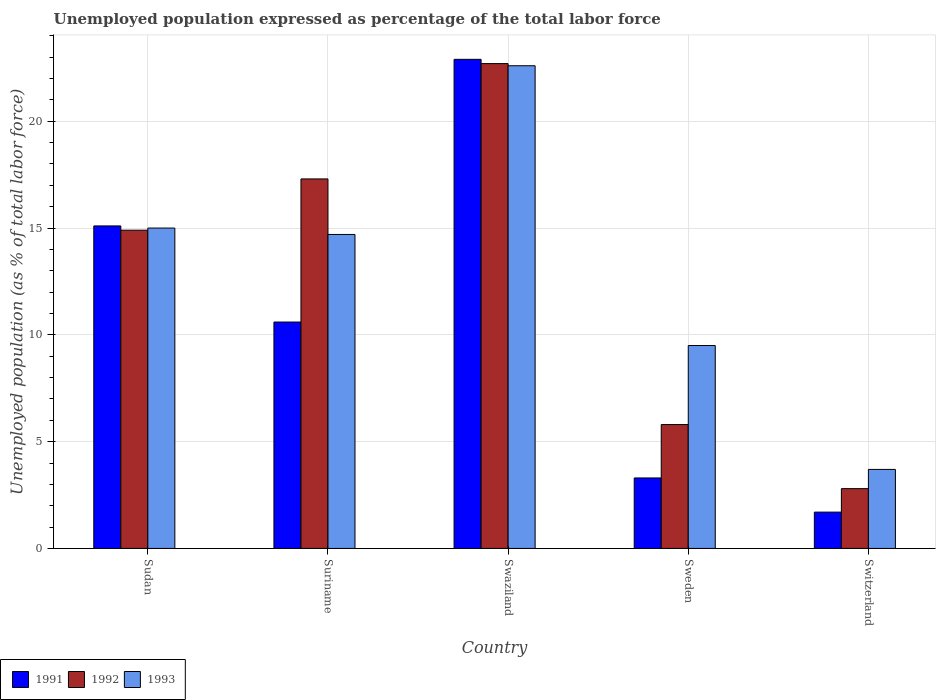Are the number of bars per tick equal to the number of legend labels?
Give a very brief answer. Yes. How many bars are there on the 3rd tick from the left?
Make the answer very short. 3. How many bars are there on the 2nd tick from the right?
Your answer should be compact. 3. What is the label of the 3rd group of bars from the left?
Your response must be concise. Swaziland. In how many cases, is the number of bars for a given country not equal to the number of legend labels?
Offer a terse response. 0. What is the unemployment in in 1992 in Sudan?
Provide a short and direct response. 14.9. Across all countries, what is the maximum unemployment in in 1992?
Offer a very short reply. 22.7. Across all countries, what is the minimum unemployment in in 1991?
Give a very brief answer. 1.7. In which country was the unemployment in in 1993 maximum?
Give a very brief answer. Swaziland. In which country was the unemployment in in 1992 minimum?
Provide a succinct answer. Switzerland. What is the total unemployment in in 1991 in the graph?
Offer a terse response. 53.6. What is the difference between the unemployment in in 1992 in Suriname and that in Sweden?
Keep it short and to the point. 11.5. What is the difference between the unemployment in in 1992 in Sudan and the unemployment in in 1993 in Swaziland?
Provide a short and direct response. -7.7. What is the average unemployment in in 1992 per country?
Your answer should be very brief. 12.7. What is the difference between the unemployment in of/in 1991 and unemployment in of/in 1993 in Sudan?
Your answer should be compact. 0.1. In how many countries, is the unemployment in in 1991 greater than 21 %?
Ensure brevity in your answer.  1. What is the ratio of the unemployment in in 1991 in Sudan to that in Switzerland?
Make the answer very short. 8.88. What is the difference between the highest and the second highest unemployment in in 1993?
Give a very brief answer. -7.9. What is the difference between the highest and the lowest unemployment in in 1991?
Provide a short and direct response. 21.2. Is the sum of the unemployment in in 1992 in Swaziland and Sweden greater than the maximum unemployment in in 1993 across all countries?
Your answer should be very brief. Yes. What does the 2nd bar from the right in Switzerland represents?
Make the answer very short. 1992. Is it the case that in every country, the sum of the unemployment in in 1993 and unemployment in in 1992 is greater than the unemployment in in 1991?
Provide a short and direct response. Yes. Where does the legend appear in the graph?
Ensure brevity in your answer.  Bottom left. How are the legend labels stacked?
Offer a terse response. Horizontal. What is the title of the graph?
Your answer should be very brief. Unemployed population expressed as percentage of the total labor force. Does "2000" appear as one of the legend labels in the graph?
Offer a very short reply. No. What is the label or title of the X-axis?
Make the answer very short. Country. What is the label or title of the Y-axis?
Your answer should be very brief. Unemployed population (as % of total labor force). What is the Unemployed population (as % of total labor force) in 1991 in Sudan?
Your answer should be compact. 15.1. What is the Unemployed population (as % of total labor force) in 1992 in Sudan?
Provide a short and direct response. 14.9. What is the Unemployed population (as % of total labor force) in 1993 in Sudan?
Offer a terse response. 15. What is the Unemployed population (as % of total labor force) in 1991 in Suriname?
Your response must be concise. 10.6. What is the Unemployed population (as % of total labor force) of 1992 in Suriname?
Your answer should be very brief. 17.3. What is the Unemployed population (as % of total labor force) of 1993 in Suriname?
Make the answer very short. 14.7. What is the Unemployed population (as % of total labor force) of 1991 in Swaziland?
Give a very brief answer. 22.9. What is the Unemployed population (as % of total labor force) of 1992 in Swaziland?
Offer a very short reply. 22.7. What is the Unemployed population (as % of total labor force) in 1993 in Swaziland?
Make the answer very short. 22.6. What is the Unemployed population (as % of total labor force) of 1991 in Sweden?
Provide a short and direct response. 3.3. What is the Unemployed population (as % of total labor force) of 1992 in Sweden?
Your answer should be very brief. 5.8. What is the Unemployed population (as % of total labor force) in 1993 in Sweden?
Provide a short and direct response. 9.5. What is the Unemployed population (as % of total labor force) in 1991 in Switzerland?
Your response must be concise. 1.7. What is the Unemployed population (as % of total labor force) of 1992 in Switzerland?
Keep it short and to the point. 2.8. What is the Unemployed population (as % of total labor force) in 1993 in Switzerland?
Your answer should be compact. 3.7. Across all countries, what is the maximum Unemployed population (as % of total labor force) in 1991?
Give a very brief answer. 22.9. Across all countries, what is the maximum Unemployed population (as % of total labor force) of 1992?
Make the answer very short. 22.7. Across all countries, what is the maximum Unemployed population (as % of total labor force) in 1993?
Give a very brief answer. 22.6. Across all countries, what is the minimum Unemployed population (as % of total labor force) in 1991?
Give a very brief answer. 1.7. Across all countries, what is the minimum Unemployed population (as % of total labor force) of 1992?
Keep it short and to the point. 2.8. Across all countries, what is the minimum Unemployed population (as % of total labor force) in 1993?
Make the answer very short. 3.7. What is the total Unemployed population (as % of total labor force) in 1991 in the graph?
Your response must be concise. 53.6. What is the total Unemployed population (as % of total labor force) of 1992 in the graph?
Your response must be concise. 63.5. What is the total Unemployed population (as % of total labor force) in 1993 in the graph?
Ensure brevity in your answer.  65.5. What is the difference between the Unemployed population (as % of total labor force) of 1991 in Sudan and that in Suriname?
Keep it short and to the point. 4.5. What is the difference between the Unemployed population (as % of total labor force) in 1992 in Sudan and that in Suriname?
Provide a succinct answer. -2.4. What is the difference between the Unemployed population (as % of total labor force) in 1993 in Sudan and that in Suriname?
Your answer should be very brief. 0.3. What is the difference between the Unemployed population (as % of total labor force) in 1993 in Sudan and that in Swaziland?
Offer a very short reply. -7.6. What is the difference between the Unemployed population (as % of total labor force) in 1991 in Suriname and that in Swaziland?
Offer a very short reply. -12.3. What is the difference between the Unemployed population (as % of total labor force) of 1993 in Suriname and that in Swaziland?
Make the answer very short. -7.9. What is the difference between the Unemployed population (as % of total labor force) of 1992 in Suriname and that in Sweden?
Provide a succinct answer. 11.5. What is the difference between the Unemployed population (as % of total labor force) of 1993 in Suriname and that in Sweden?
Your answer should be compact. 5.2. What is the difference between the Unemployed population (as % of total labor force) in 1991 in Suriname and that in Switzerland?
Ensure brevity in your answer.  8.9. What is the difference between the Unemployed population (as % of total labor force) in 1991 in Swaziland and that in Sweden?
Your answer should be compact. 19.6. What is the difference between the Unemployed population (as % of total labor force) in 1992 in Swaziland and that in Sweden?
Your answer should be compact. 16.9. What is the difference between the Unemployed population (as % of total labor force) of 1993 in Swaziland and that in Sweden?
Make the answer very short. 13.1. What is the difference between the Unemployed population (as % of total labor force) of 1991 in Swaziland and that in Switzerland?
Ensure brevity in your answer.  21.2. What is the difference between the Unemployed population (as % of total labor force) in 1992 in Swaziland and that in Switzerland?
Your response must be concise. 19.9. What is the difference between the Unemployed population (as % of total labor force) in 1993 in Swaziland and that in Switzerland?
Your answer should be compact. 18.9. What is the difference between the Unemployed population (as % of total labor force) in 1991 in Sweden and that in Switzerland?
Make the answer very short. 1.6. What is the difference between the Unemployed population (as % of total labor force) of 1991 in Sudan and the Unemployed population (as % of total labor force) of 1993 in Suriname?
Your answer should be very brief. 0.4. What is the difference between the Unemployed population (as % of total labor force) of 1992 in Sudan and the Unemployed population (as % of total labor force) of 1993 in Suriname?
Give a very brief answer. 0.2. What is the difference between the Unemployed population (as % of total labor force) of 1991 in Sudan and the Unemployed population (as % of total labor force) of 1992 in Swaziland?
Offer a very short reply. -7.6. What is the difference between the Unemployed population (as % of total labor force) of 1991 in Sudan and the Unemployed population (as % of total labor force) of 1993 in Sweden?
Give a very brief answer. 5.6. What is the difference between the Unemployed population (as % of total labor force) in 1992 in Sudan and the Unemployed population (as % of total labor force) in 1993 in Sweden?
Make the answer very short. 5.4. What is the difference between the Unemployed population (as % of total labor force) of 1991 in Sudan and the Unemployed population (as % of total labor force) of 1992 in Switzerland?
Ensure brevity in your answer.  12.3. What is the difference between the Unemployed population (as % of total labor force) in 1992 in Sudan and the Unemployed population (as % of total labor force) in 1993 in Switzerland?
Make the answer very short. 11.2. What is the difference between the Unemployed population (as % of total labor force) of 1991 in Suriname and the Unemployed population (as % of total labor force) of 1992 in Swaziland?
Provide a succinct answer. -12.1. What is the difference between the Unemployed population (as % of total labor force) of 1991 in Suriname and the Unemployed population (as % of total labor force) of 1993 in Sweden?
Ensure brevity in your answer.  1.1. What is the difference between the Unemployed population (as % of total labor force) of 1991 in Swaziland and the Unemployed population (as % of total labor force) of 1992 in Sweden?
Your response must be concise. 17.1. What is the difference between the Unemployed population (as % of total labor force) of 1991 in Swaziland and the Unemployed population (as % of total labor force) of 1992 in Switzerland?
Make the answer very short. 20.1. What is the difference between the Unemployed population (as % of total labor force) in 1992 in Swaziland and the Unemployed population (as % of total labor force) in 1993 in Switzerland?
Offer a very short reply. 19. What is the difference between the Unemployed population (as % of total labor force) in 1991 in Sweden and the Unemployed population (as % of total labor force) in 1992 in Switzerland?
Make the answer very short. 0.5. What is the average Unemployed population (as % of total labor force) of 1991 per country?
Give a very brief answer. 10.72. What is the difference between the Unemployed population (as % of total labor force) of 1991 and Unemployed population (as % of total labor force) of 1993 in Sudan?
Provide a short and direct response. 0.1. What is the difference between the Unemployed population (as % of total labor force) in 1992 and Unemployed population (as % of total labor force) in 1993 in Sudan?
Offer a very short reply. -0.1. What is the difference between the Unemployed population (as % of total labor force) in 1991 and Unemployed population (as % of total labor force) in 1993 in Suriname?
Give a very brief answer. -4.1. What is the difference between the Unemployed population (as % of total labor force) of 1992 and Unemployed population (as % of total labor force) of 1993 in Suriname?
Keep it short and to the point. 2.6. What is the difference between the Unemployed population (as % of total labor force) in 1991 and Unemployed population (as % of total labor force) in 1992 in Sweden?
Make the answer very short. -2.5. What is the difference between the Unemployed population (as % of total labor force) in 1991 and Unemployed population (as % of total labor force) in 1993 in Sweden?
Make the answer very short. -6.2. What is the difference between the Unemployed population (as % of total labor force) in 1992 and Unemployed population (as % of total labor force) in 1993 in Sweden?
Give a very brief answer. -3.7. What is the ratio of the Unemployed population (as % of total labor force) of 1991 in Sudan to that in Suriname?
Provide a short and direct response. 1.42. What is the ratio of the Unemployed population (as % of total labor force) of 1992 in Sudan to that in Suriname?
Offer a very short reply. 0.86. What is the ratio of the Unemployed population (as % of total labor force) in 1993 in Sudan to that in Suriname?
Give a very brief answer. 1.02. What is the ratio of the Unemployed population (as % of total labor force) of 1991 in Sudan to that in Swaziland?
Your answer should be very brief. 0.66. What is the ratio of the Unemployed population (as % of total labor force) in 1992 in Sudan to that in Swaziland?
Your answer should be very brief. 0.66. What is the ratio of the Unemployed population (as % of total labor force) of 1993 in Sudan to that in Swaziland?
Your answer should be compact. 0.66. What is the ratio of the Unemployed population (as % of total labor force) of 1991 in Sudan to that in Sweden?
Offer a very short reply. 4.58. What is the ratio of the Unemployed population (as % of total labor force) of 1992 in Sudan to that in Sweden?
Ensure brevity in your answer.  2.57. What is the ratio of the Unemployed population (as % of total labor force) in 1993 in Sudan to that in Sweden?
Provide a short and direct response. 1.58. What is the ratio of the Unemployed population (as % of total labor force) of 1991 in Sudan to that in Switzerland?
Keep it short and to the point. 8.88. What is the ratio of the Unemployed population (as % of total labor force) of 1992 in Sudan to that in Switzerland?
Your answer should be compact. 5.32. What is the ratio of the Unemployed population (as % of total labor force) of 1993 in Sudan to that in Switzerland?
Provide a short and direct response. 4.05. What is the ratio of the Unemployed population (as % of total labor force) of 1991 in Suriname to that in Swaziland?
Give a very brief answer. 0.46. What is the ratio of the Unemployed population (as % of total labor force) of 1992 in Suriname to that in Swaziland?
Make the answer very short. 0.76. What is the ratio of the Unemployed population (as % of total labor force) of 1993 in Suriname to that in Swaziland?
Provide a short and direct response. 0.65. What is the ratio of the Unemployed population (as % of total labor force) in 1991 in Suriname to that in Sweden?
Provide a short and direct response. 3.21. What is the ratio of the Unemployed population (as % of total labor force) of 1992 in Suriname to that in Sweden?
Keep it short and to the point. 2.98. What is the ratio of the Unemployed population (as % of total labor force) in 1993 in Suriname to that in Sweden?
Offer a terse response. 1.55. What is the ratio of the Unemployed population (as % of total labor force) in 1991 in Suriname to that in Switzerland?
Give a very brief answer. 6.24. What is the ratio of the Unemployed population (as % of total labor force) in 1992 in Suriname to that in Switzerland?
Your response must be concise. 6.18. What is the ratio of the Unemployed population (as % of total labor force) of 1993 in Suriname to that in Switzerland?
Keep it short and to the point. 3.97. What is the ratio of the Unemployed population (as % of total labor force) in 1991 in Swaziland to that in Sweden?
Make the answer very short. 6.94. What is the ratio of the Unemployed population (as % of total labor force) of 1992 in Swaziland to that in Sweden?
Make the answer very short. 3.91. What is the ratio of the Unemployed population (as % of total labor force) in 1993 in Swaziland to that in Sweden?
Your answer should be very brief. 2.38. What is the ratio of the Unemployed population (as % of total labor force) in 1991 in Swaziland to that in Switzerland?
Provide a succinct answer. 13.47. What is the ratio of the Unemployed population (as % of total labor force) in 1992 in Swaziland to that in Switzerland?
Your answer should be compact. 8.11. What is the ratio of the Unemployed population (as % of total labor force) of 1993 in Swaziland to that in Switzerland?
Ensure brevity in your answer.  6.11. What is the ratio of the Unemployed population (as % of total labor force) of 1991 in Sweden to that in Switzerland?
Keep it short and to the point. 1.94. What is the ratio of the Unemployed population (as % of total labor force) of 1992 in Sweden to that in Switzerland?
Ensure brevity in your answer.  2.07. What is the ratio of the Unemployed population (as % of total labor force) in 1993 in Sweden to that in Switzerland?
Offer a terse response. 2.57. What is the difference between the highest and the second highest Unemployed population (as % of total labor force) in 1991?
Your response must be concise. 7.8. What is the difference between the highest and the second highest Unemployed population (as % of total labor force) of 1992?
Your answer should be very brief. 5.4. What is the difference between the highest and the lowest Unemployed population (as % of total labor force) in 1991?
Ensure brevity in your answer.  21.2. What is the difference between the highest and the lowest Unemployed population (as % of total labor force) in 1992?
Provide a succinct answer. 19.9. 